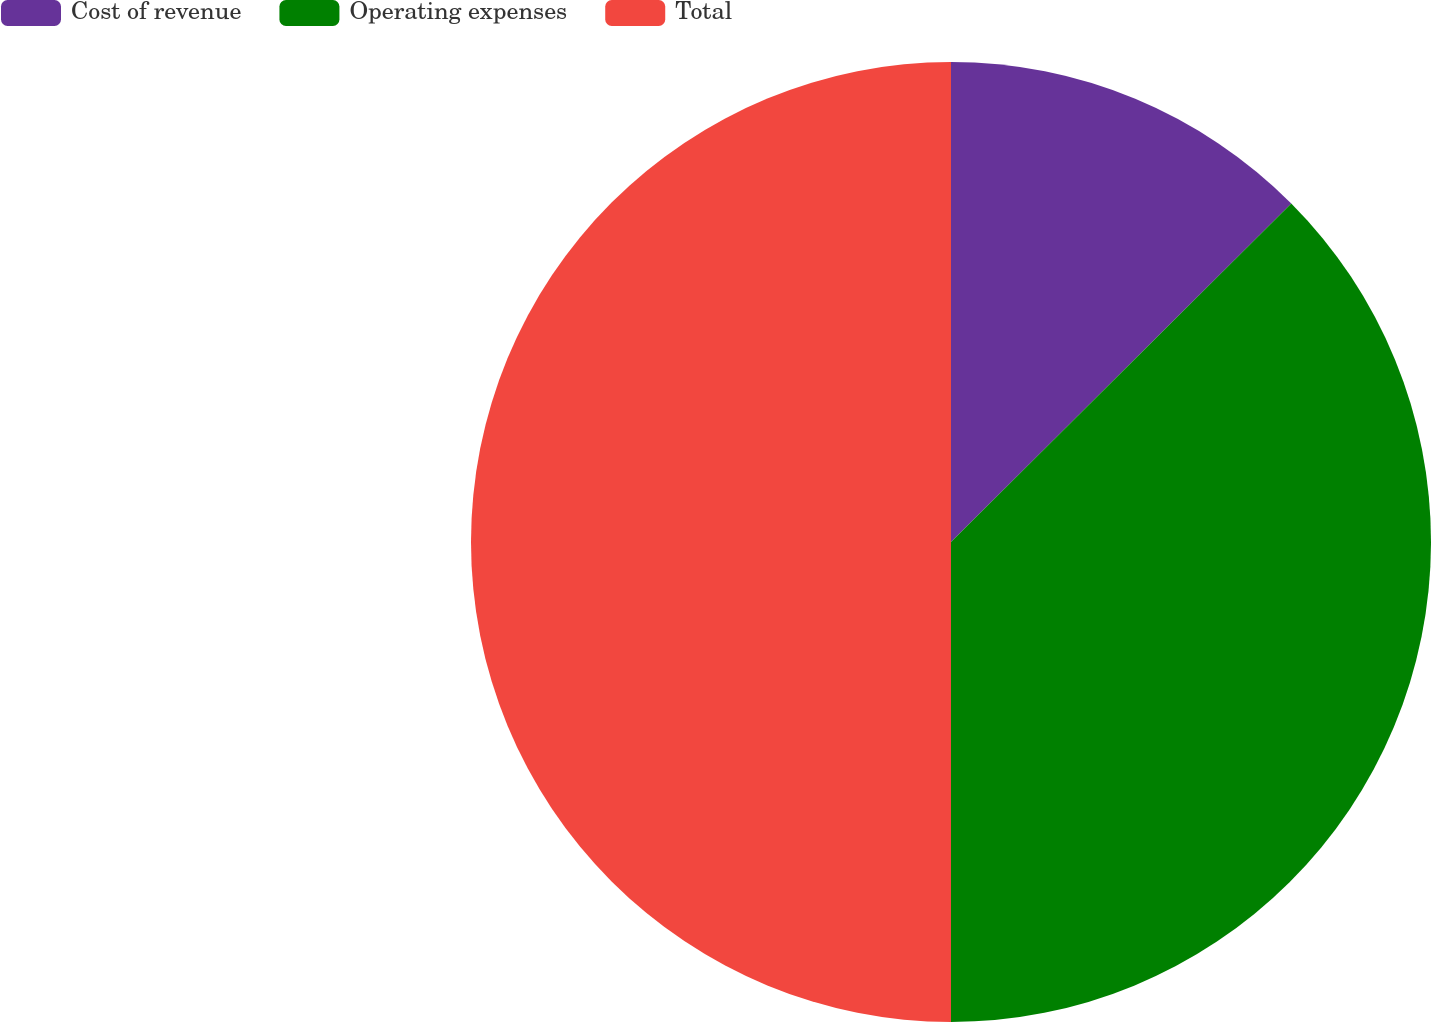Convert chart to OTSL. <chart><loc_0><loc_0><loc_500><loc_500><pie_chart><fcel>Cost of revenue<fcel>Operating expenses<fcel>Total<nl><fcel>12.54%<fcel>37.46%<fcel>50.0%<nl></chart> 